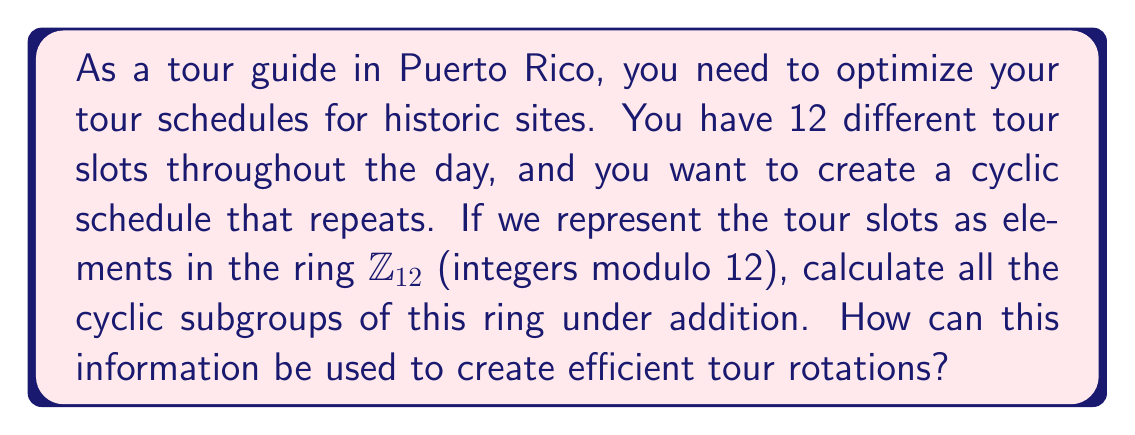Can you answer this question? To solve this problem, we need to follow these steps:

1) First, let's recall that in the ring $\mathbb{Z}_{12}$, the elements are $\{0, 1, 2, ..., 11\}$.

2) To find the cyclic subgroups, we need to consider each element of $\mathbb{Z}_{12}$ and generate the subgroup it creates under addition modulo 12.

3) For each element $a \in \mathbb{Z}_{12}$, the cyclic subgroup generated by $a$ is:

   $\langle a \rangle = \{na \mod 12 : n \in \mathbb{Z}\}$

4) Let's calculate each subgroup:

   $\langle 0 \rangle = \{0\}$
   $\langle 1 \rangle = \{0, 1, 2, 3, 4, 5, 6, 7, 8, 9, 10, 11\}$ (This is the entire group)
   $\langle 2 \rangle = \{0, 2, 4, 6, 8, 10\}$
   $\langle 3 \rangle = \{0, 3, 6, 9\}$
   $\langle 4 \rangle = \{0, 4, 8\}$
   $\langle 5 \rangle = \{0, 5, 10, 3, 8, 1, 6, 11, 4, 9, 2, 7\}$ (This is also the entire group)
   $\langle 6 \rangle = \{0, 6\}$
   $\langle 7 \rangle = \{0, 7, 2, 9, 4, 11, 6, 1, 8, 3, 10, 5\}$ (This is also the entire group)
   $\langle 8 \rangle = \{0, 8, 4\}$
   $\langle 9 \rangle = \{0, 9, 6, 3\}$
   $\langle 10 \rangle = \{0, 10, 8, 6, 4, 2\}$
   $\langle 11 \rangle = \{0, 11, 10, 9, 8, 7, 6, 5, 4, 3, 2, 1\}$ (This is also the entire group)

5) These subgroups represent different ways to cycle through the tour slots. For example:

   - $\langle 2 \rangle$ represents a schedule that visits every other slot (0, 2, 4, 6, 8, 10).
   - $\langle 3 \rangle$ represents a schedule that visits every third slot (0, 3, 6, 9).
   - $\langle 4 \rangle$ represents a schedule that visits every fourth slot (0, 4, 8).

6) The tour guide can use these subgroups to create efficient rotations. For instance:
   - If they want to cover all sites in 6 tours, they could use the schedule from $\langle 2 \rangle$.
   - If they want to cover all sites in 4 tours, they could use the schedule from $\langle 3 \rangle$.
   - If they want to cover all sites in 3 tours, they could use the schedule from $\langle 4 \rangle$.

This allows for flexible scheduling based on the number of tours the guide wants to conduct while ensuring all sites are visited in a cyclic manner.
Answer: The cyclic subgroups of $\mathbb{Z}_{12}$ under addition are:

$\langle 0 \rangle = \{0\}$
$\langle 1 \rangle = \langle 5 \rangle = \langle 7 \rangle = \langle 11 \rangle = \{0, 1, 2, 3, 4, 5, 6, 7, 8, 9, 10, 11\}$
$\langle 2 \rangle = \langle 10 \rangle = \{0, 2, 4, 6, 8, 10\}$
$\langle 3 \rangle = \langle 9 \rangle = \{0, 3, 6, 9\}$
$\langle 4 \rangle = \langle 8 \rangle = \{0, 4, 8\}$
$\langle 6 \rangle = \{0, 6\}$

These subgroups can be used to create efficient tour rotations by selecting a subgroup that matches the desired number of tours while ensuring all sites are visited cyclically. 